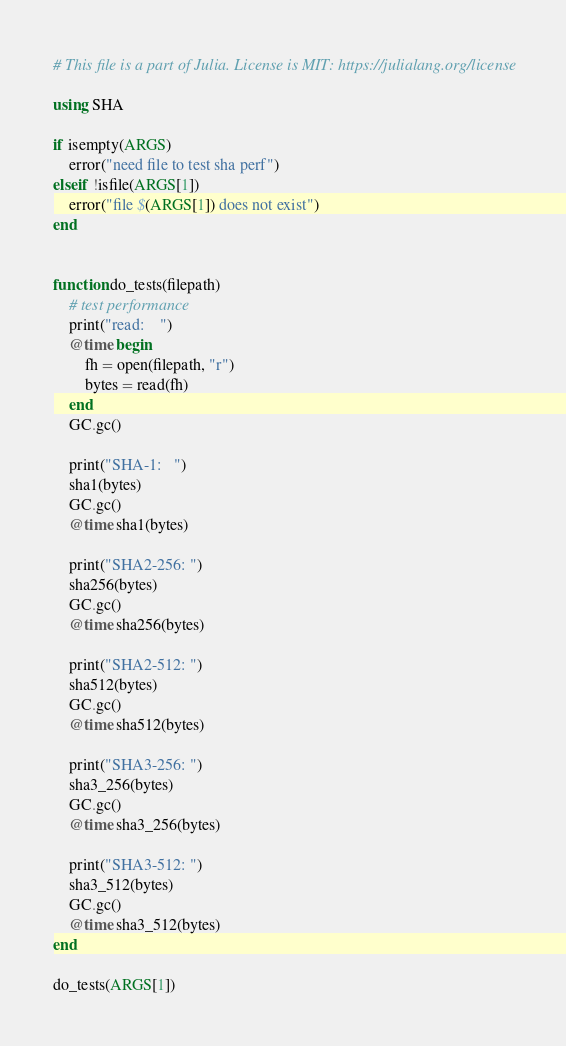Convert code to text. <code><loc_0><loc_0><loc_500><loc_500><_Julia_># This file is a part of Julia. License is MIT: https://julialang.org/license

using SHA

if isempty(ARGS)
    error("need file to test sha perf")
elseif !isfile(ARGS[1])
    error("file $(ARGS[1]) does not exist")
end


function do_tests(filepath)
    # test performance
    print("read:    ")
    @time begin
        fh = open(filepath, "r")
        bytes = read(fh)
    end
    GC.gc()

    print("SHA-1:   ")
    sha1(bytes)
    GC.gc()
    @time sha1(bytes)

    print("SHA2-256: ")
    sha256(bytes)
    GC.gc()
    @time sha256(bytes)

    print("SHA2-512: ")
    sha512(bytes)
    GC.gc()
    @time sha512(bytes)

    print("SHA3-256: ")
    sha3_256(bytes)
    GC.gc()
    @time sha3_256(bytes)

    print("SHA3-512: ")
    sha3_512(bytes)
    GC.gc()
    @time sha3_512(bytes)
end

do_tests(ARGS[1])
</code> 